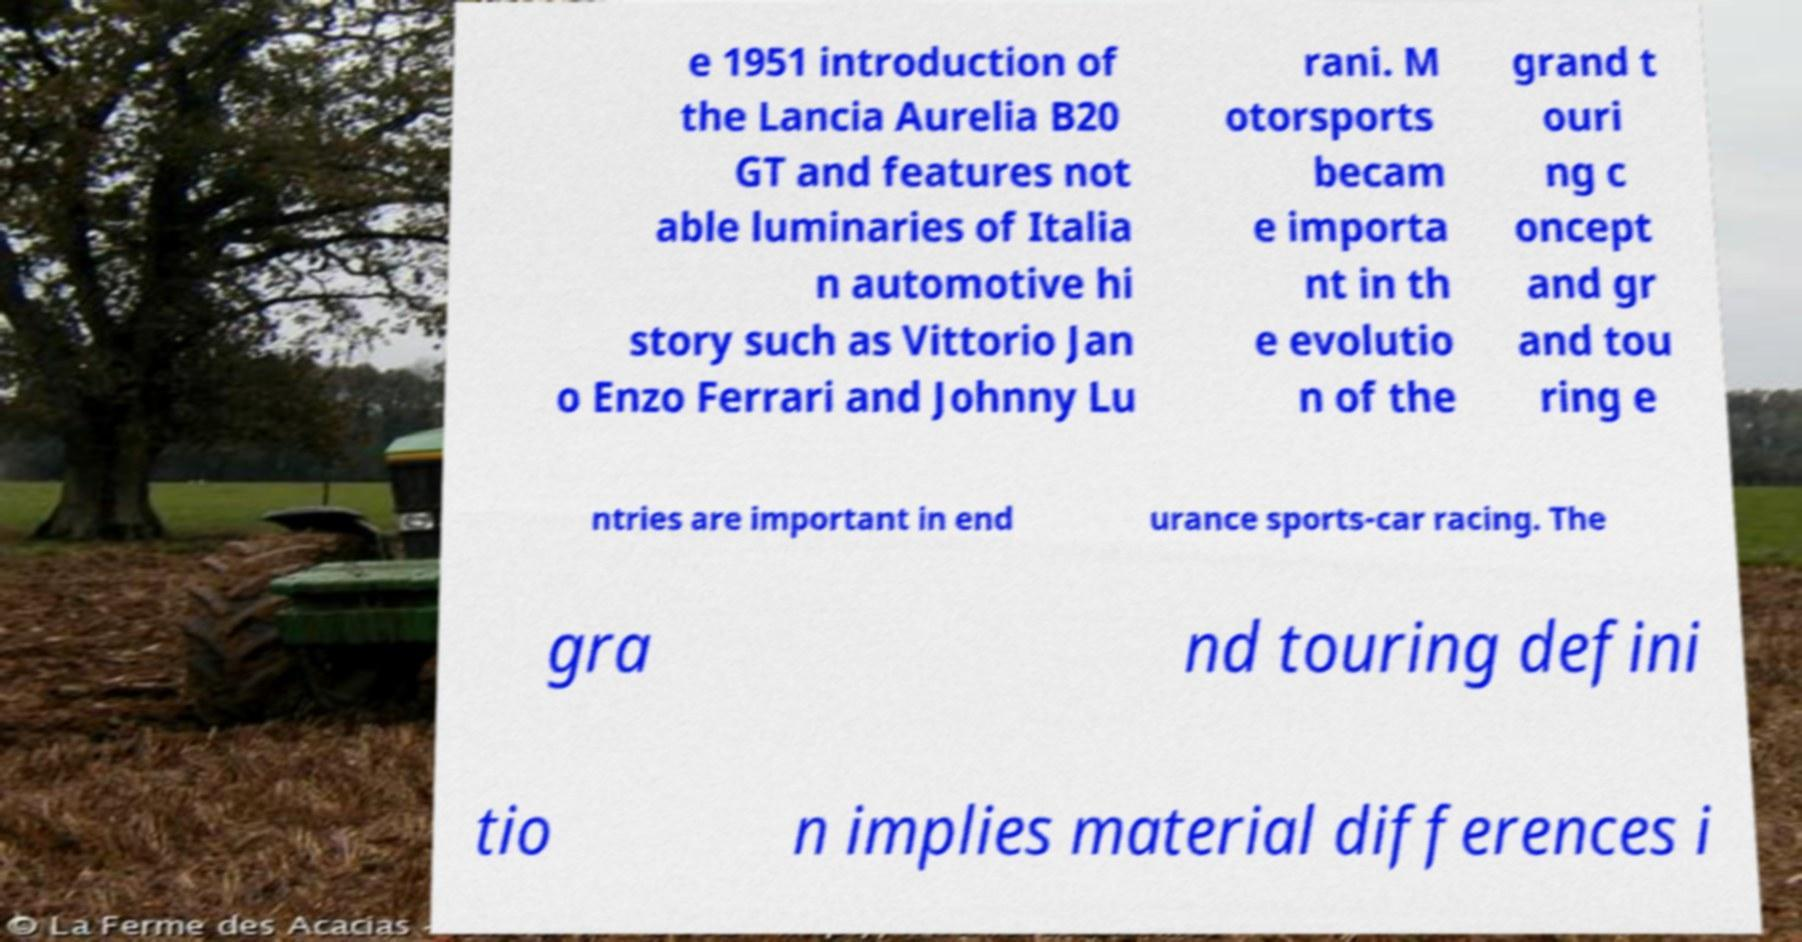Could you assist in decoding the text presented in this image and type it out clearly? e 1951 introduction of the Lancia Aurelia B20 GT and features not able luminaries of Italia n automotive hi story such as Vittorio Jan o Enzo Ferrari and Johnny Lu rani. M otorsports becam e importa nt in th e evolutio n of the grand t ouri ng c oncept and gr and tou ring e ntries are important in end urance sports-car racing. The gra nd touring defini tio n implies material differences i 